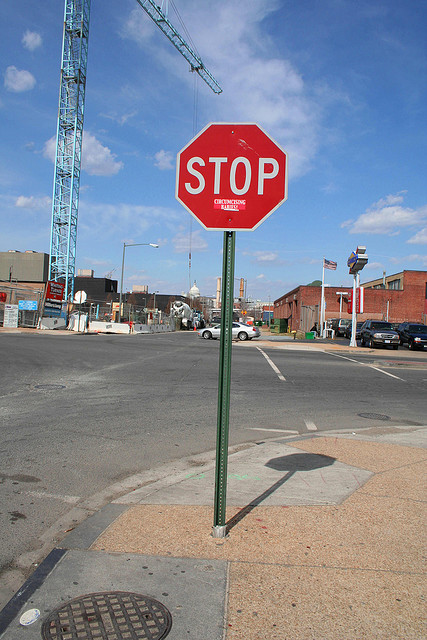Extract all visible text content from this image. STOP SIERO 